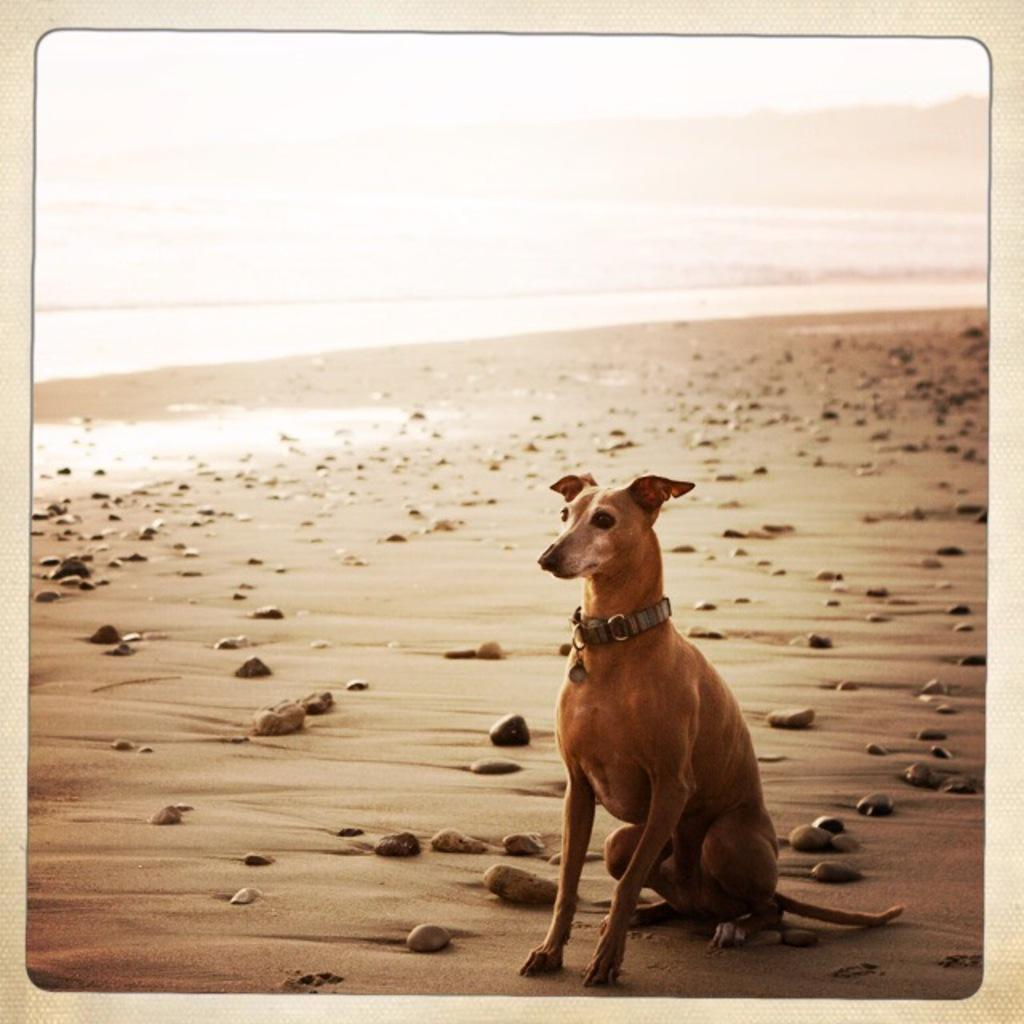What animal can be seen in the image? There is a dog in the image. Where is the dog sitting? The dog is sitting on a sand surface. What else can be found on the sand surface? There are stones on the sand surface. What is located near the dog? Water is visible near the dog. What type of plant is the dog using to breathe in the image? There is no plant present in the image, and the dog is not using any plant to breathe. 